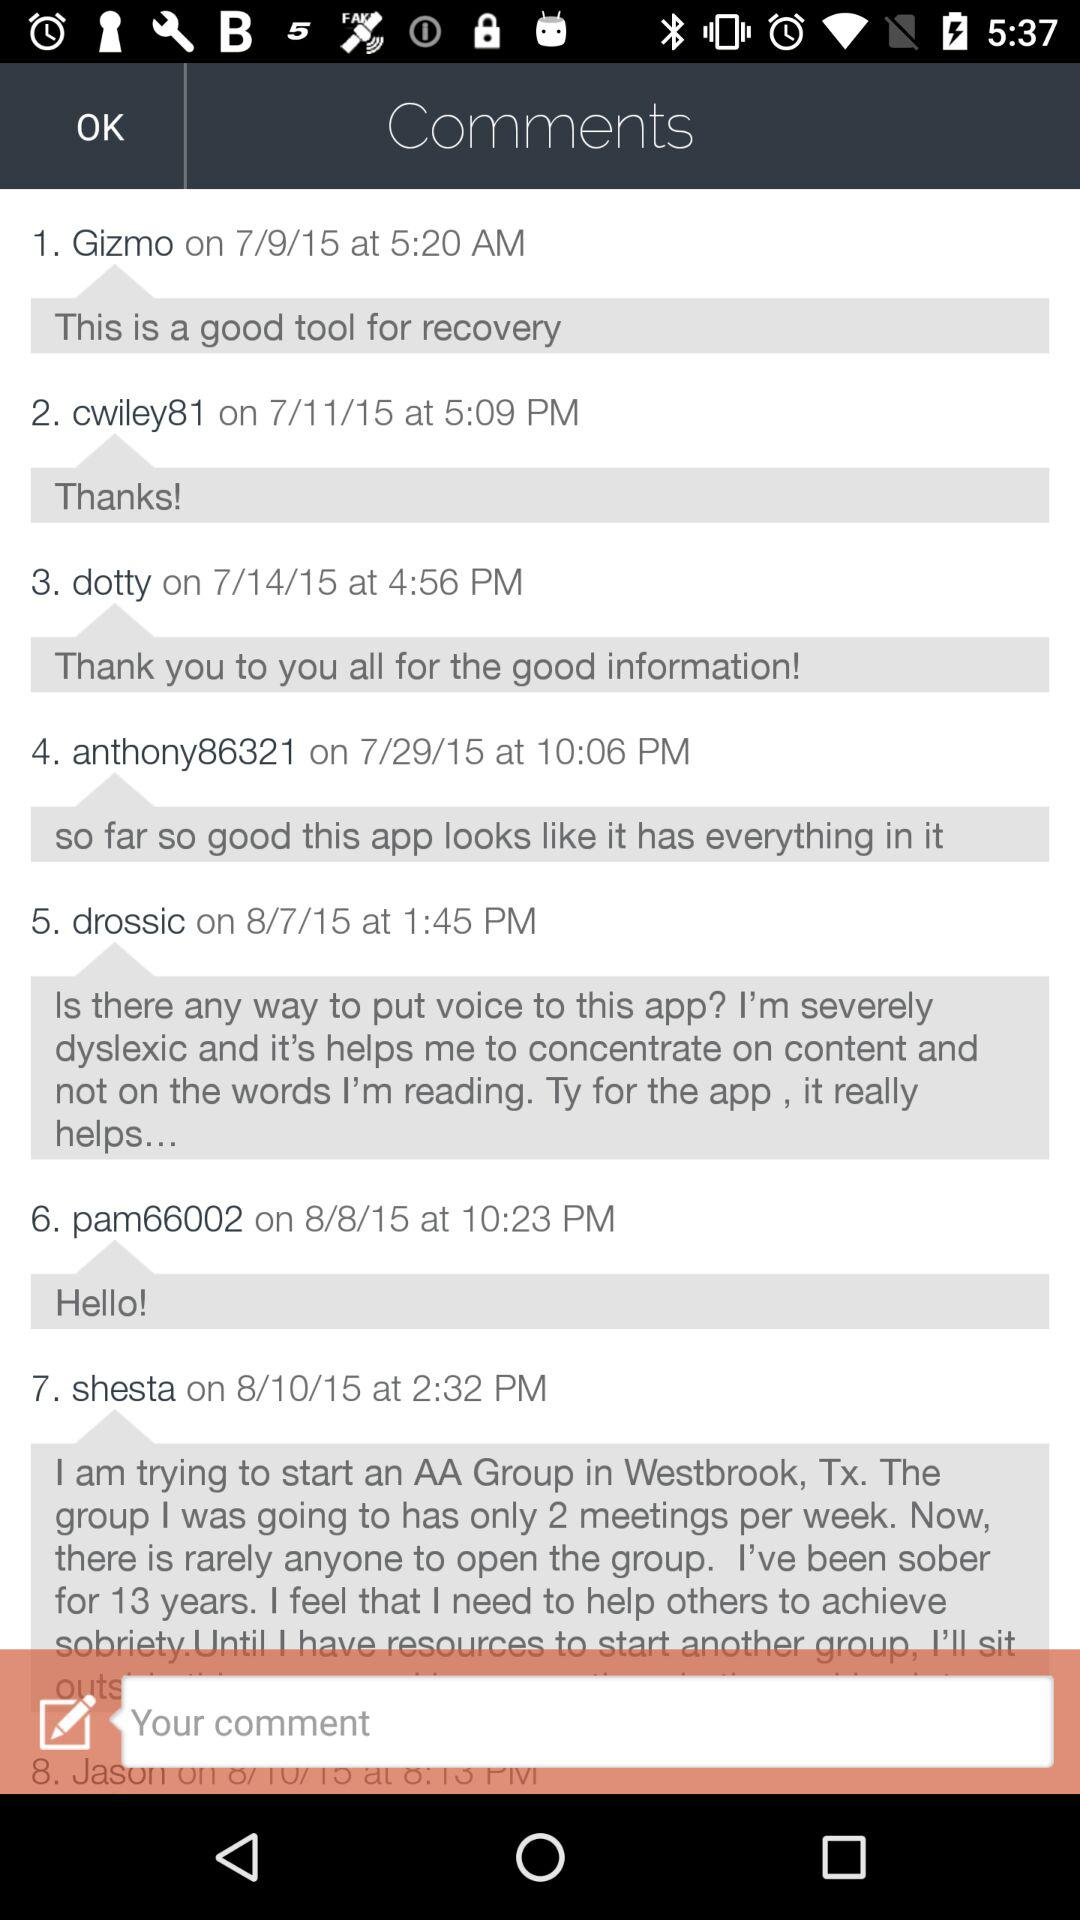How many comments are there before the text input?
Answer the question using a single word or phrase. 7 